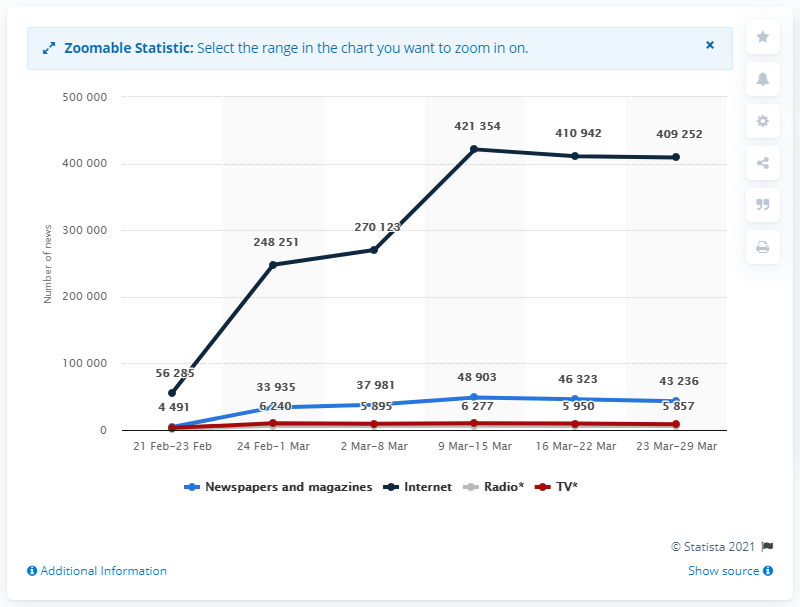Can we determine the exact number of news releases for radio during the last week shown in the chart? Yes, the graph illustrates that in the week of March 23-29, Radio had exactly 5,857 news releases, as indicated by the red dot corresponding to that time period. 